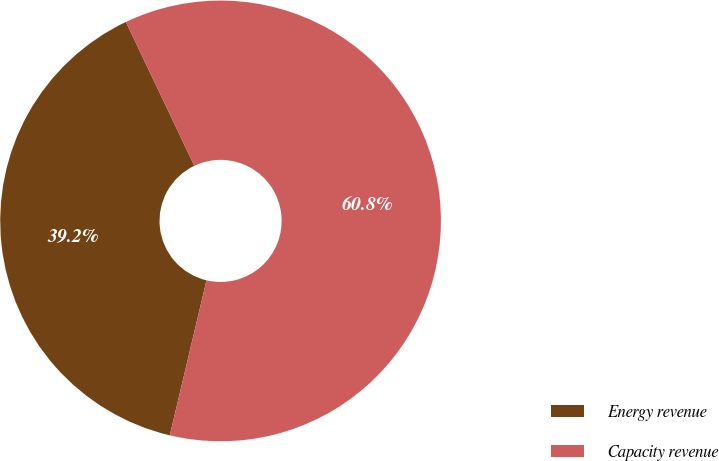Convert chart. <chart><loc_0><loc_0><loc_500><loc_500><pie_chart><fcel>Energy revenue<fcel>Capacity revenue<nl><fcel>39.23%<fcel>60.77%<nl></chart> 